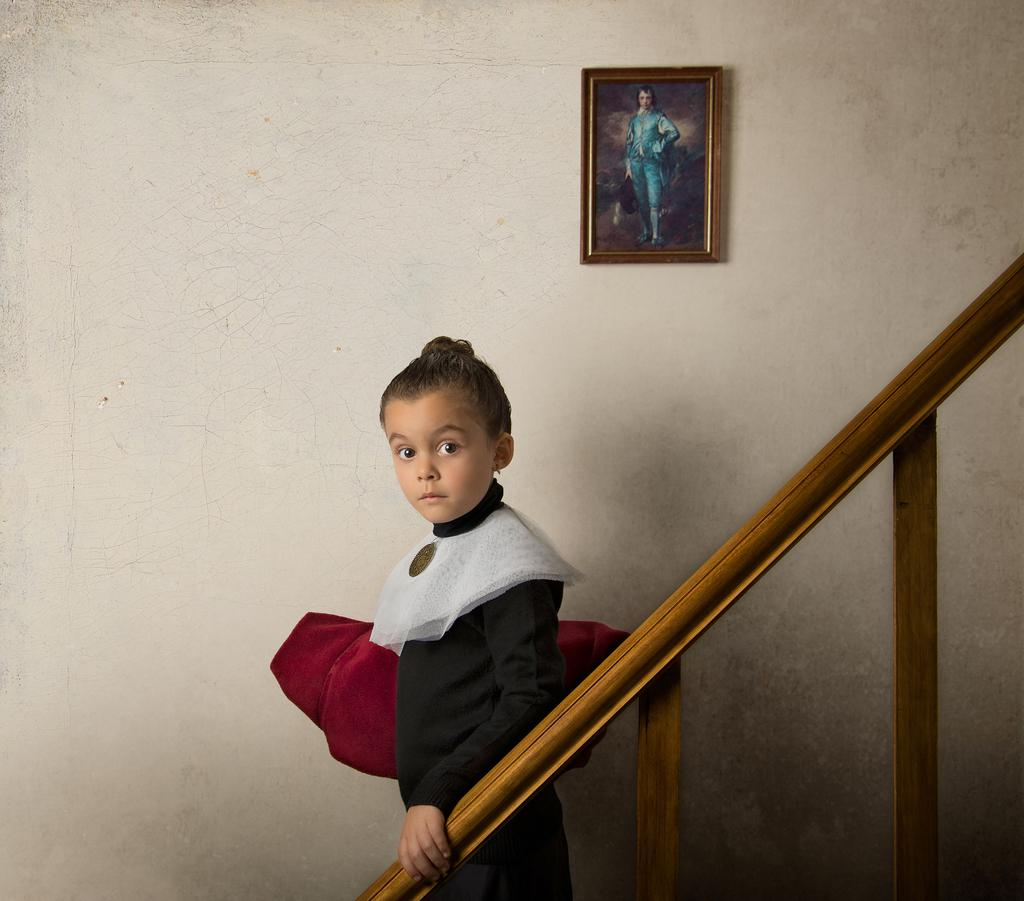Who is the main subject in the image? There is a small girl in the image. What is the girl's position in relation to the wall? The girl is standing in front of a wall. Who or what is the girl looking at? The girl is looking at someone. What type of trouble is the girl causing in the image? There is no indication of trouble in the image; the girl is simply standing in front of a wall and looking at someone. 